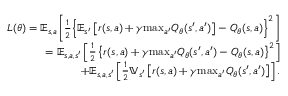<formula> <loc_0><loc_0><loc_500><loc_500>\begin{array} { r } { L ( \theta ) = \mathbb { E } _ { s , a } \left [ \frac { 1 } { 2 } \left \{ \mathbb { E } _ { s ^ { \prime } } \left [ r ( s , a ) + \gamma \max _ { a ^ { \prime } } Q _ { \theta } ( s ^ { \prime } , a ^ { \prime } ) \right ] - Q _ { \theta } ( s , a ) \right \} ^ { 2 } \right ] } \\ { = \mathbb { E } _ { s , a , s ^ { \prime } } \left [ \frac { 1 } { 2 } \left \{ r ( s , a ) + \gamma \max _ { a ^ { \prime } } Q _ { \theta } ( s ^ { \prime } , a ^ { \prime } ) - Q _ { \theta } ( s , a ) \right \} ^ { 2 } \right ] } \\ { + \mathbb { E } _ { s , a , s ^ { \prime } } \left [ \frac { 1 } { 2 } \mathbb { V } _ { s ^ { \prime } } \left [ r ( s , a ) + \gamma \max _ { a ^ { \prime } } Q _ { \theta } ( s ^ { \prime } , a ^ { \prime } ) \right ] \right ] . } \end{array}</formula> 